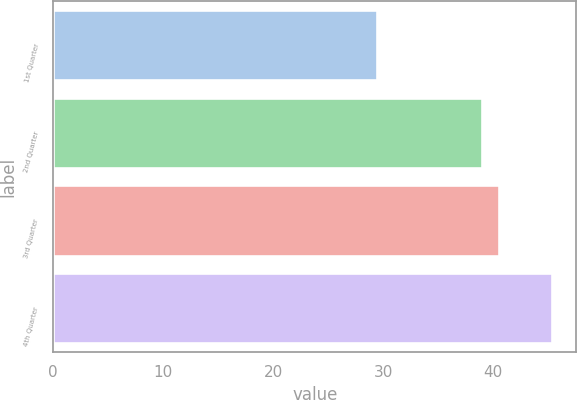Convert chart. <chart><loc_0><loc_0><loc_500><loc_500><bar_chart><fcel>1st Quarter<fcel>2nd Quarter<fcel>3rd Quarter<fcel>4th Quarter<nl><fcel>29.45<fcel>38.97<fcel>40.55<fcel>45.3<nl></chart> 